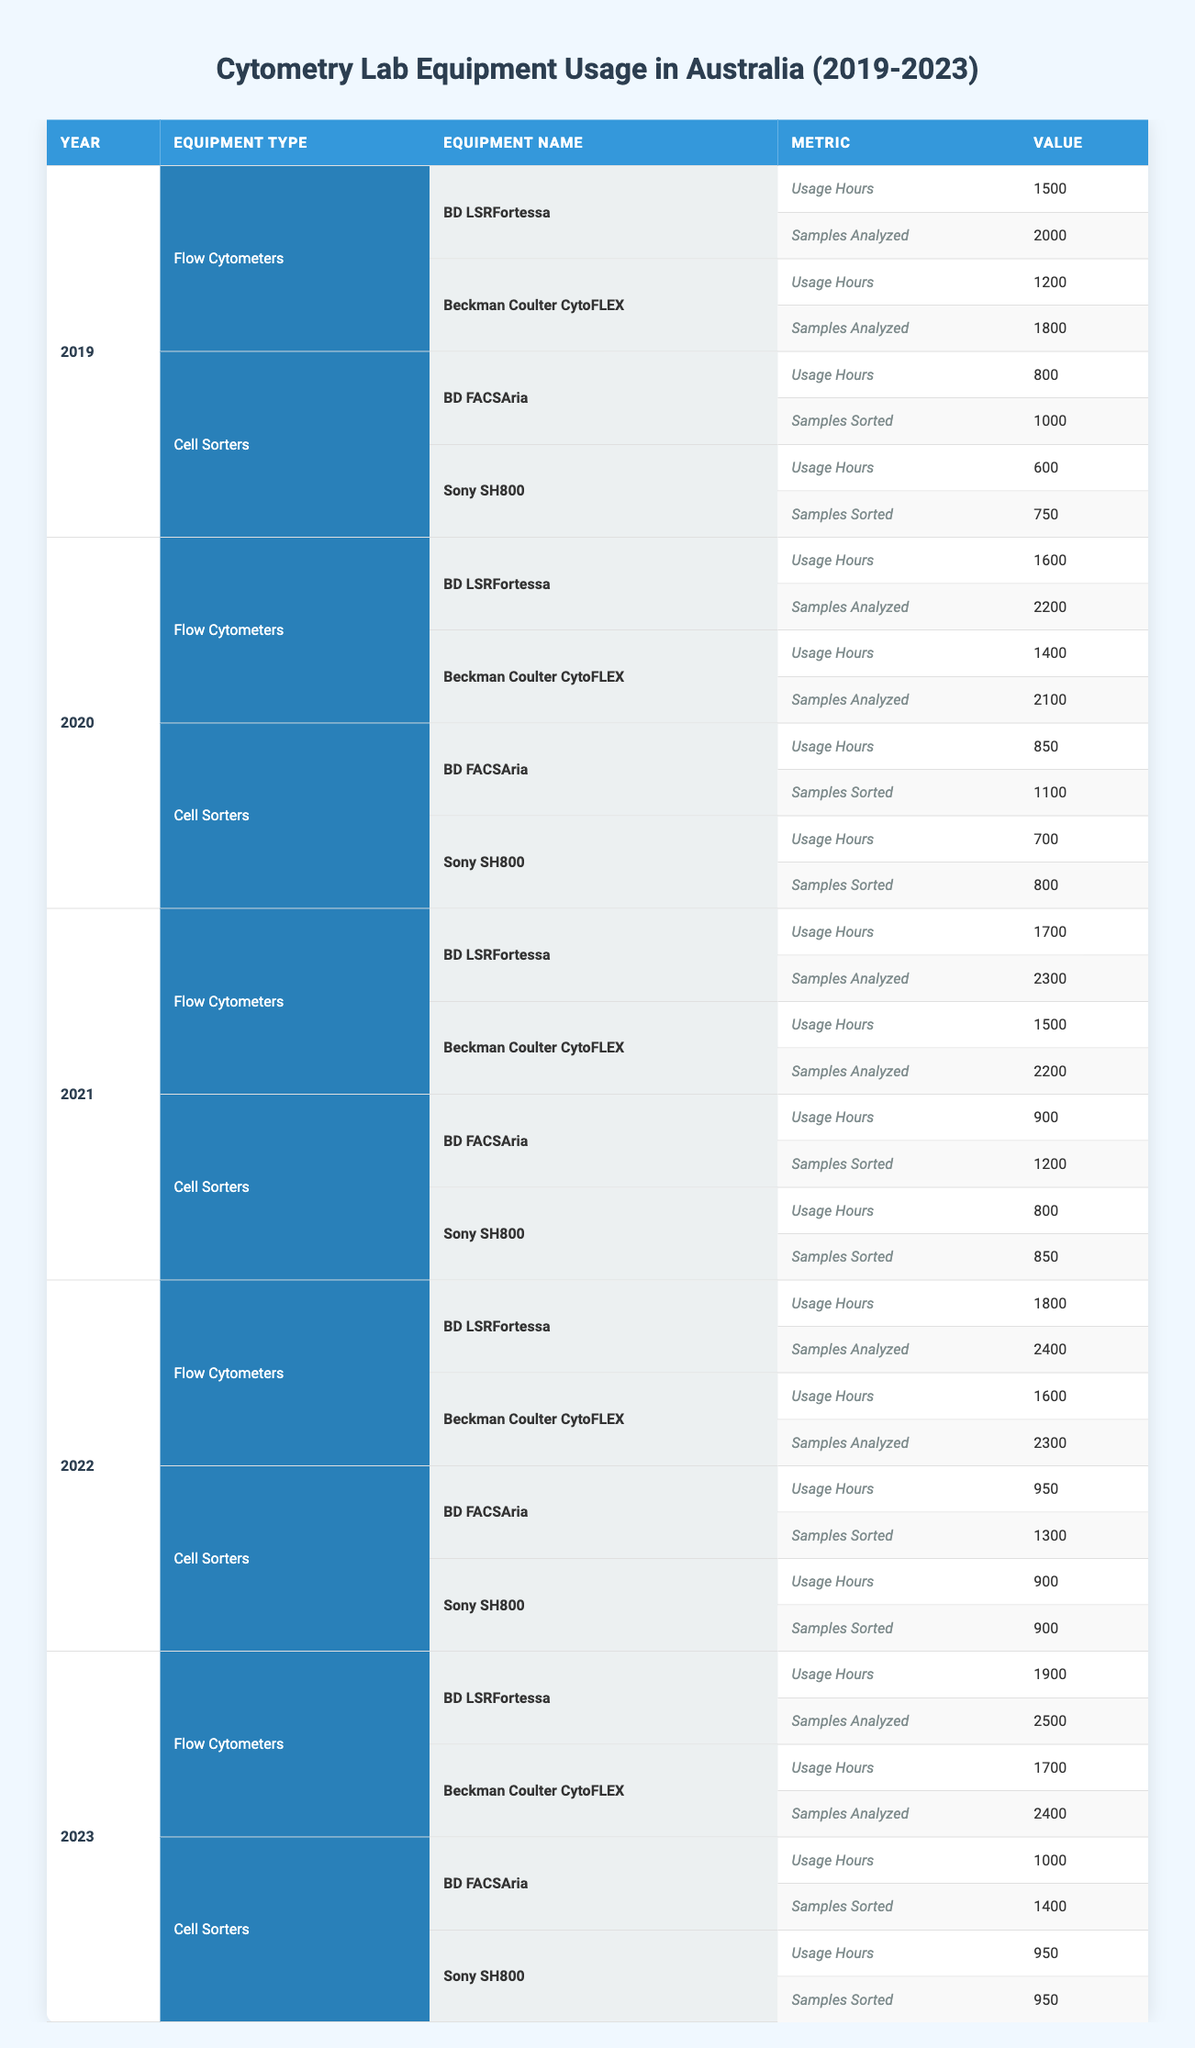What were the usage hours for BD LSRFortessa in 2022? In the row corresponding to the year 2022 and the equipment type Flow Cytometers, I look for BD LSRFortessa. The usage hours are listed as 1800.
Answer: 1800 How many samples were analyzed using Beckman Coulter CytoFLEX in 2021? I find the year 2021 in the table, check under Flow Cytometers, then look for Beckman Coulter CytoFLEX. The samples analyzed are indicated as 2200.
Answer: 2200 Which equipment type had the highest cumulative usage hours in 2023? I will sum up the usage hours for each equipment type in 2023: For Flow Cytometers, it's 1900 + 1700 = 3600; for Cell Sorters, it's 1000 + 950 = 1950. The highest total is for Flow Cytometers with 3600 hours.
Answer: Flow Cytometers Did the usage hours for Sony SH800 increase from 2020 to 2023? I compare the usage hours for Sony SH800 in both years: In 2020, it was 700 hours, and in 2023, it was 950 hours. Since 950 is greater than 700, the usage hours did increase.
Answer: Yes What was the average number of samples sorted using BD FACSAria from 2019 to 2023? I gather the number of samples sorted for BD FACSAria: 1000 (2019) + 1100 (2020) + 1200 (2021) + 1300 (2022) + 1400 (2023) = 5000. There are 5 data points, so the average is 5000 divided by 5, which equals 1000.
Answer: 1000 Was the number of samples analyzed greater for BD LSRFortessa than Beckman Coulter CytoFLEX in 2022? Checking the samples analyzed for both in 2022, BD LSRFortessa had 2400 and Beckman Coulter CytoFLEX had 2300. Since 2400 is greater than 2300, the statement is true.
Answer: Yes How many additional usage hours did BD FACSAria have in 2020 compared to 2019? From the 2020 data, BD FACSAria had usage hours of 850, and in 2019, it had 800 hours. To find the additional hours, I subtract the 2019 value from the 2020 value, which gives 850 - 800 = 50 additional hours.
Answer: 50 Was there a downward trend in samples sorted by Sony SH800 over the five years? Looking at the samples sorted by Sony SH800 over the years: 750 (2019), 800 (2020), 850 (2021), 900 (2022), and 950 (2023), it shows an upward trend instead. Thus, there is no downward trend.
Answer: No 